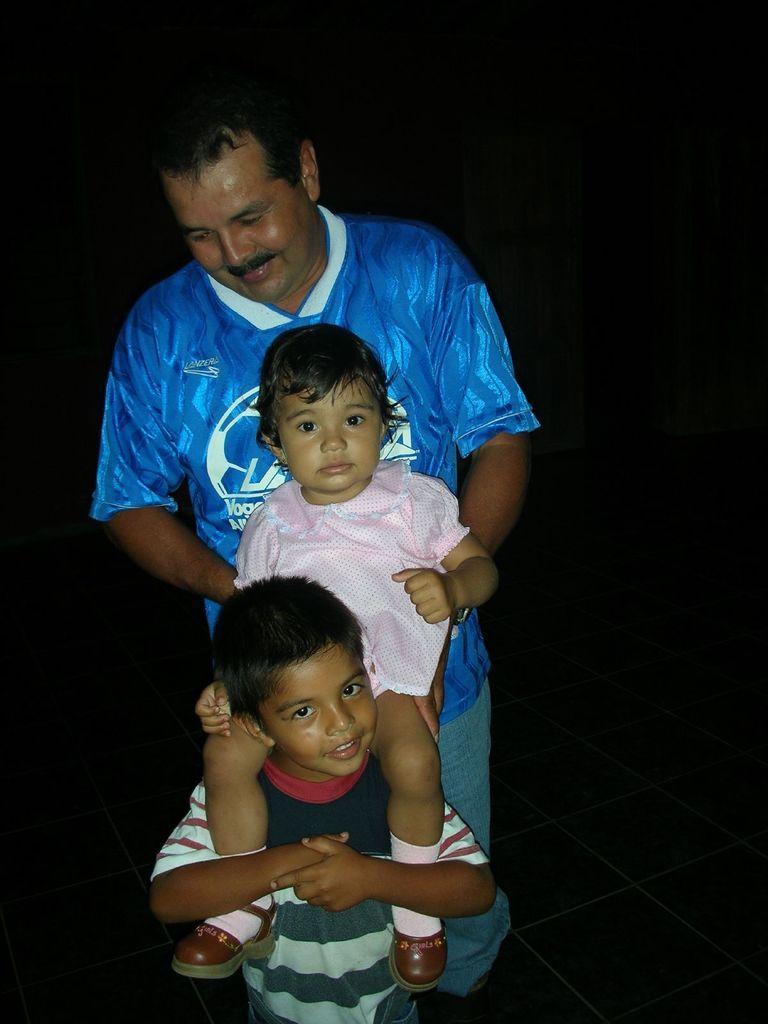Can you describe this image briefly? In this picture we can see three people,they are one boy,one girl,one man and in the background we can see it is dark. 